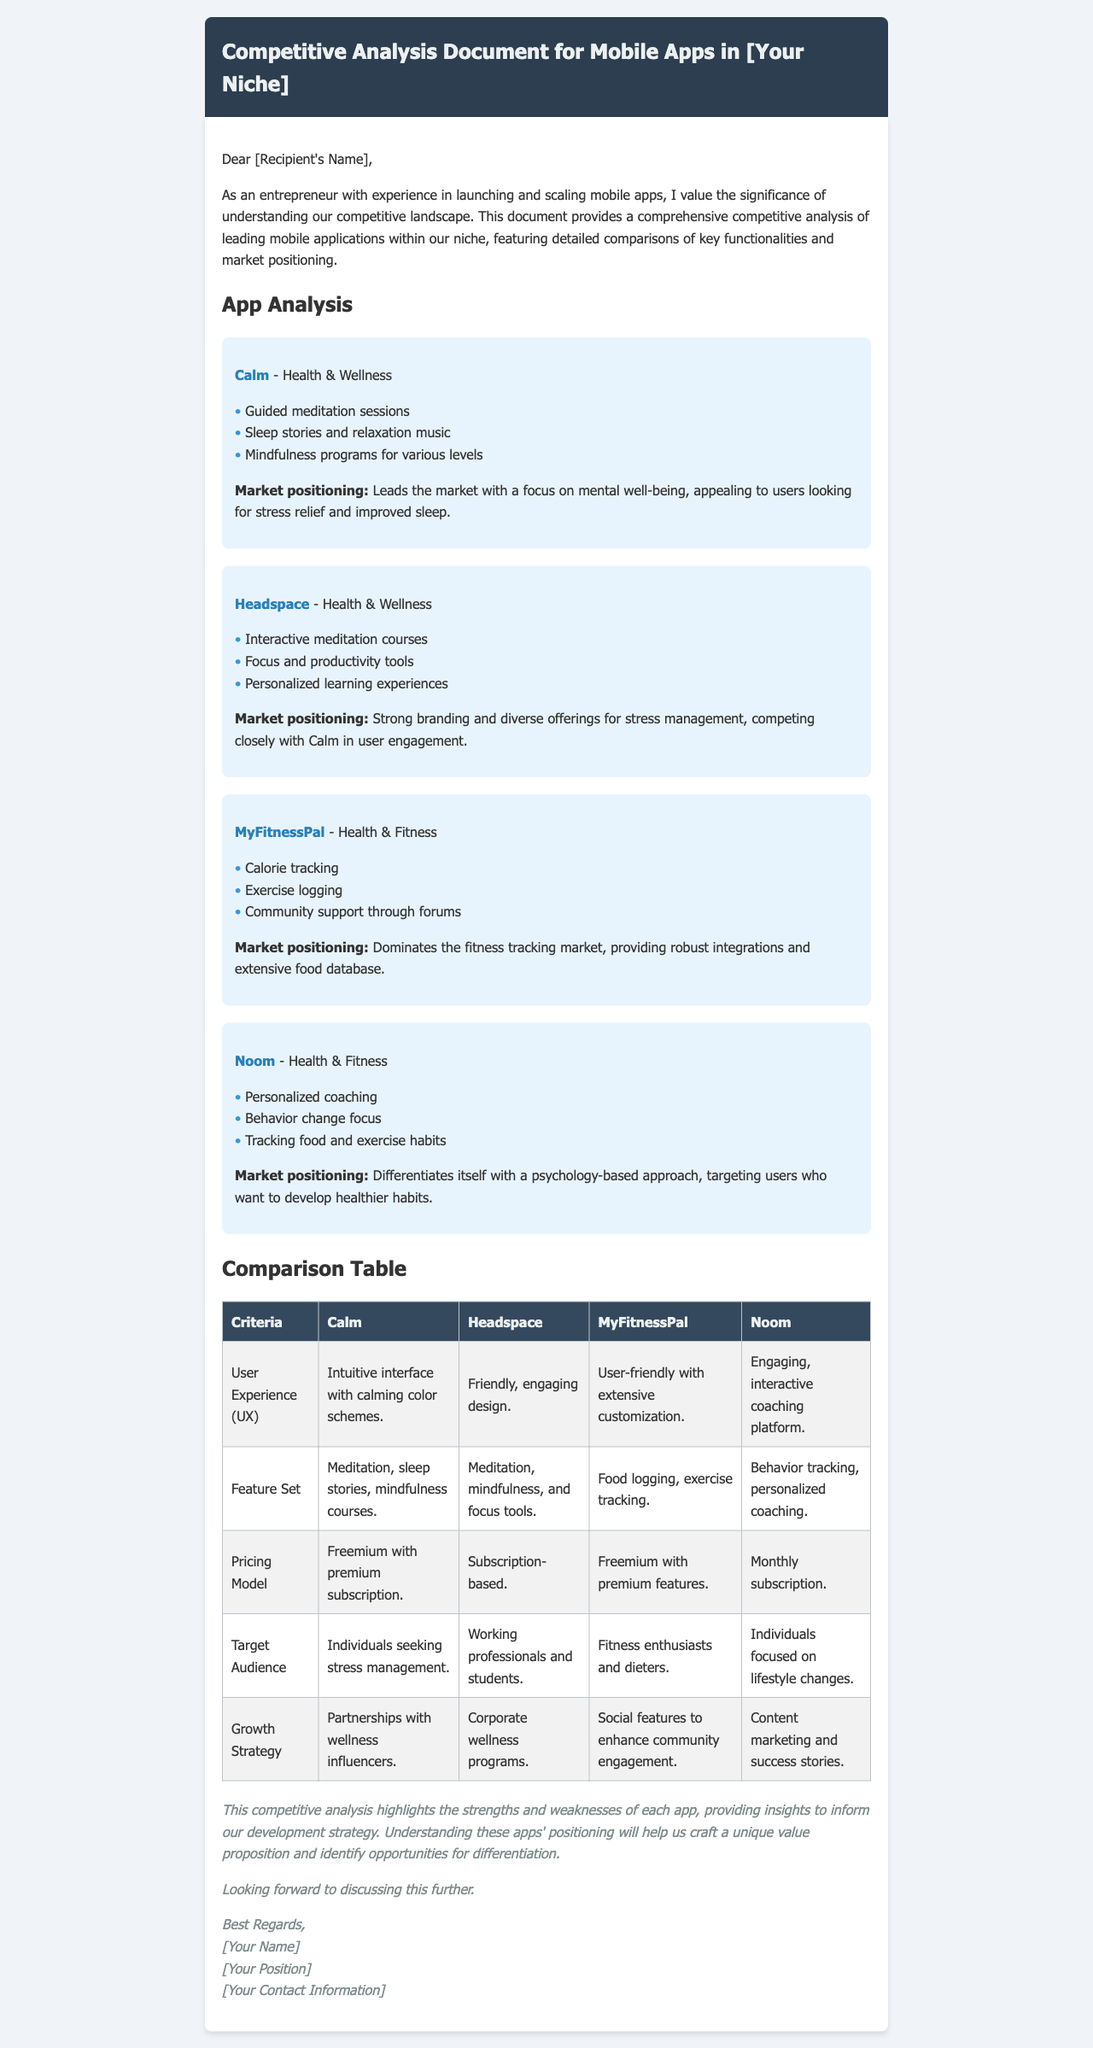What is the title of the document? The title is stated in the header of the document, emphasizing it is a Competitive Analysis Document for Mobile Apps in a specific niche.
Answer: Competitive Analysis Document for Mobile Apps in [Your Niche] Who is the app Calm targeted towards? The target audience is specified in the table under the Target Audience criteria for the Calm app.
Answer: Individuals seeking stress management What pricing model does MyFitnessPal use? The pricing model is detailed in the comparison table under the Pricing Model criteria for MyFitnessPal.
Answer: Freemium with premium features Name a feature of the app Noom. Features are listed for each app. A specific feature of Noom can be found in its feature list.
Answer: Personalized coaching Which app focuses on sleep stories? The feature list for Calm indicates its offerings, including sleep stories, differentiating it from others.
Answer: Calm What is the market positioning of Headspace? Market positioning is provided for each app in the app analysis section, specifically for Headspace.
Answer: Strong branding and diverse offerings for stress management Which app is noted for community support through forums? This information is present in the feature list for MyFitnessPal, identifying its unique aspect among others.
Answer: MyFitnessPal What criterion mentions intuitive interface design? This criterion is present in the comparison table under User Experience, highlighting the design quality of Calm.
Answer: User Experience (UX) How does Noom differentiate itself in the market? The unique approach of Noom is outlined in its market positioning, indicating how it stands out.
Answer: Psychology-based approach 